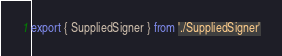<code> <loc_0><loc_0><loc_500><loc_500><_TypeScript_>export { SuppliedSigner } from './SuppliedSigner'
</code> 